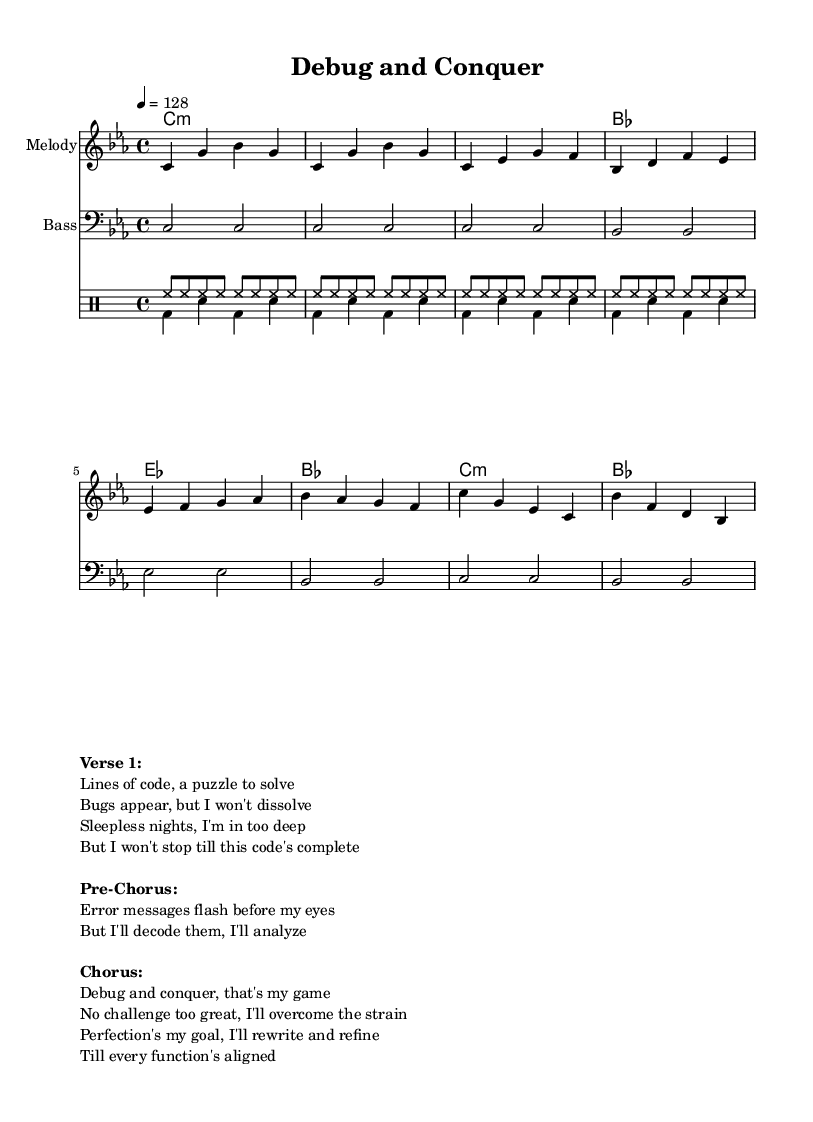What is the key signature of this music? The key signature is C minor, which has three flats: B flat, E flat, and A flat. It's noted at the beginning of the staff before the time signature.
Answer: C minor What is the time signature of the piece? The time signature is 4/4, which means there are four beats in each measure and the quarter note gets one beat. This is indicated at the beginning of the score right after the key signature.
Answer: 4/4 What is the tempo marking for the music? The tempo marking is 128 beats per minute, as indicated in the tempo directive at the beginning of the score. This sets a fast and energetic pace typical of upbeat electronic dance music.
Answer: 128 How many measures are in the melody section? The melody consists of 12 measures, which can be counted from the melody staff. Each line in the melody has 4 measures, and there are 3 lines in total.
Answer: 12 What is the main theme of the lyrics? The main theme of the lyrics is about problem-solving and overcoming challenges, as reflected in the phrases discussing debugging, analyzing errors, and striving for perfection in code. This is clear from the verses, pre-chorus, and chorus.
Answer: Problem-solving How many drum patterns are indicated in the score? There are two distinct drum patterns indicated in the score: one for the hi-hat and one for the bass drum/snare. Each of these patterns has a specific rhythm and role in the overall composition.
Answer: Two What is the function of the bass line in this music? The function of the bass line is to provide harmonic support and depth to the music, as it underpins the chords and complements the melody, which is typical in electronic dance music. It plays a simple yet effective pattern that aligns with the chord changes.
Answer: Harmonic support 